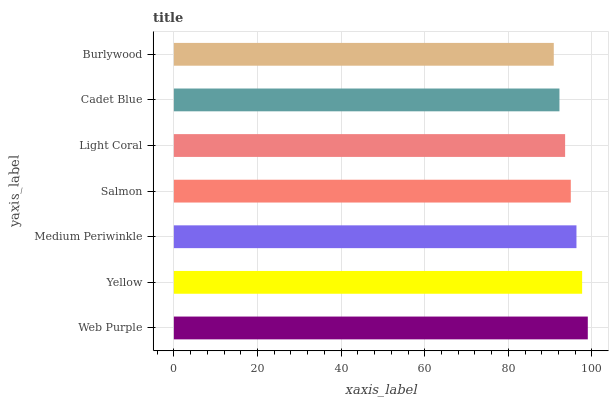Is Burlywood the minimum?
Answer yes or no. Yes. Is Web Purple the maximum?
Answer yes or no. Yes. Is Yellow the minimum?
Answer yes or no. No. Is Yellow the maximum?
Answer yes or no. No. Is Web Purple greater than Yellow?
Answer yes or no. Yes. Is Yellow less than Web Purple?
Answer yes or no. Yes. Is Yellow greater than Web Purple?
Answer yes or no. No. Is Web Purple less than Yellow?
Answer yes or no. No. Is Salmon the high median?
Answer yes or no. Yes. Is Salmon the low median?
Answer yes or no. Yes. Is Yellow the high median?
Answer yes or no. No. Is Medium Periwinkle the low median?
Answer yes or no. No. 